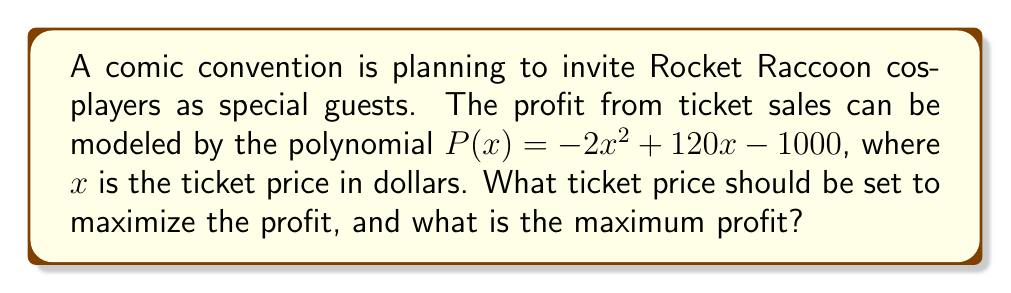Can you solve this math problem? To find the maximum profit, we need to follow these steps:

1) The profit function is a quadratic polynomial: $P(x) = -2x^2 + 120x - 1000$

2) For a quadratic function in the form $ax^2 + bx + c$, the x-coordinate of the vertex (which gives the maximum or minimum) is given by $x = -\frac{b}{2a}$

3) In our case, $a = -2$, $b = 120$, and $c = -1000$

4) Calculating the x-coordinate of the vertex:

   $x = -\frac{120}{2(-2)} = -\frac{120}{-4} = 30$

5) This means the profit is maximized when the ticket price is $30

6) To find the maximum profit, we substitute $x = 30$ into the original function:

   $P(30) = -2(30)^2 + 120(30) - 1000$
          $= -2(900) + 3600 - 1000$
          $= -1800 + 3600 - 1000$
          $= 800$

Therefore, the maximum profit is $800 when the ticket price is set to $30.
Answer: $30; $800 